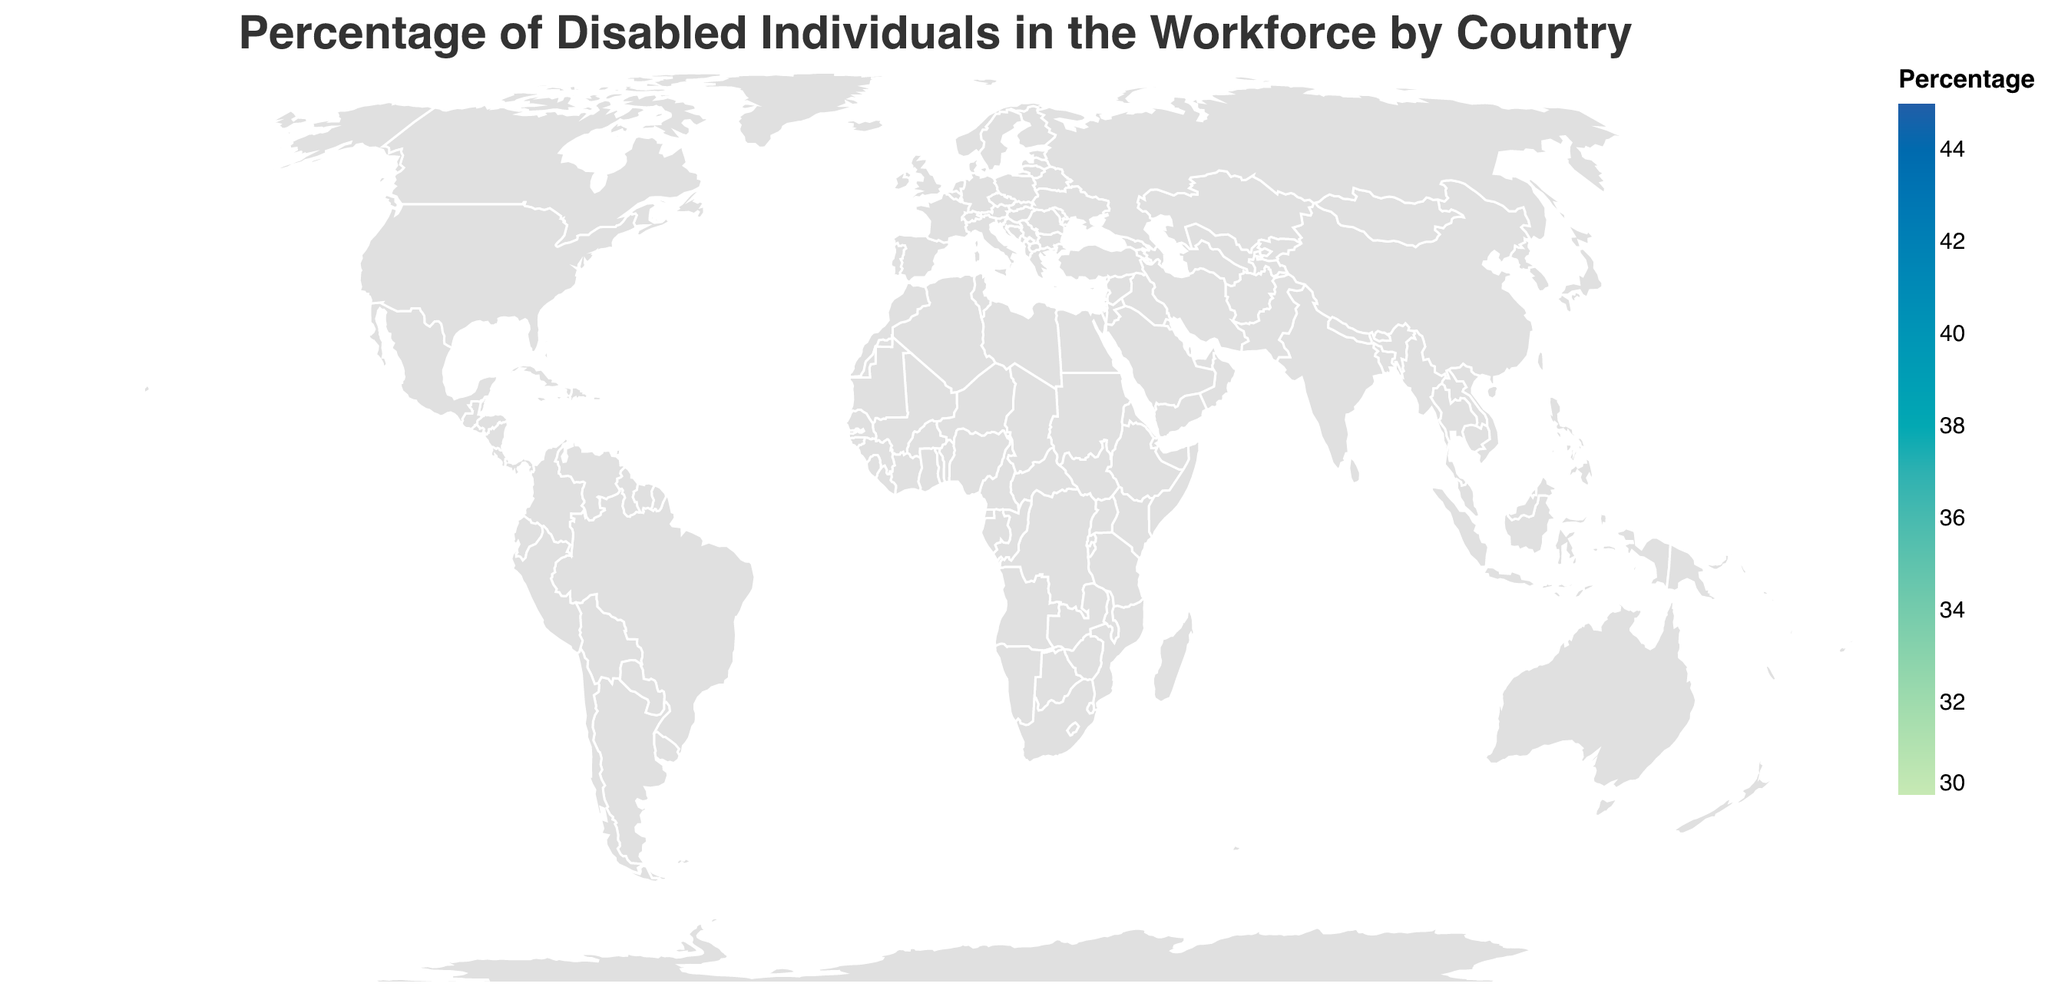What is the title of the plot? The title is located at the top of the figure and indicates the focus of the plot. It reads, "Percentage of Disabled Individuals in the Workforce by Country."
Answer: Percentage of Disabled Individuals in the Workforce by Country Which country has the highest percentage of disabled individuals in the workforce? By observing the colors and the tooltip on the map, we can see that Norway has the highest percentage, highlighted with the darkest color and showing 44.3%.
Answer: Norway What is the percentage of disabled individuals in the workforce in the United States? By finding the United States on the map and viewing the tooltip, we can see the percentage listed as 34.1%.
Answer: 34.1% Compare the percentage of disabled individuals in the workforce between Sweden and Denmark. Which country has a higher percentage? By looking at the colors of Sweden and Denmark on the map and verifying with the tooltip, Sweden has a percentage of 41.2% compared to Denmark's 39.7%, making Sweden higher.
Answer: Sweden What is the difference in the percentage of disabled individuals in the workforce between Canada and Australia? Canada has a percentage of 34.9%, and Australia has 33.6%. Subtracting these figures gives 34.9% - 33.6% = 1.3%.
Answer: 1.3% Which countries have a percentage of disabled individuals in the workforce greater than 40%? By analyzing the tooltip data on the map, Norway (44.3%), Sweden (41.2%), and Switzerland (40.8%) each have percentages greater than 40%.
Answer: Norway, Sweden, Switzerland What is the median percentage of disabled individuals in the workforce across all countries shown? Listing the percentages in ascending order (32.8, 33.2, 33.6, 34.1, 34.9, 35.7, 36.3, 36.8, 37.2, 37.9, 38.5, 39.7, 40.8, 41.2, 44.3) and finding the middle value, the median is 36.8%.
Answer: 36.8% Identify the countries with the least and the most percentage of disabled individuals in the workforce. By comparing the tooltip data on all countries, Norway has the highest percentage at 44.3%, and Israel has the lowest at 32.8%.
Answer: Norway, Israel 